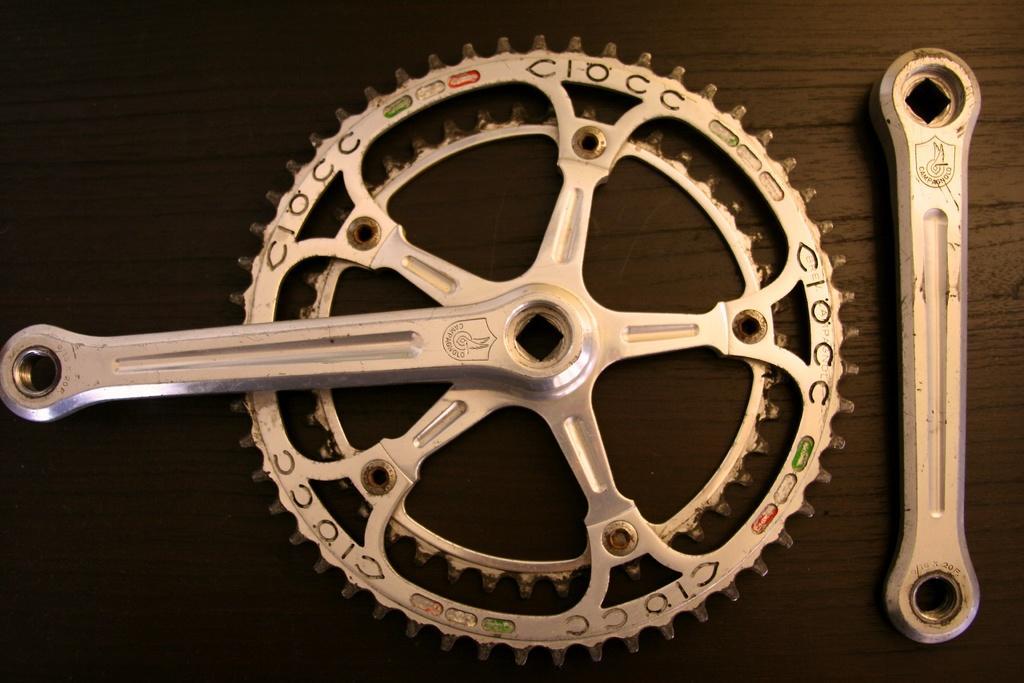Could you give a brief overview of what you see in this image? As we can see in the image there is bicycle crankset. 